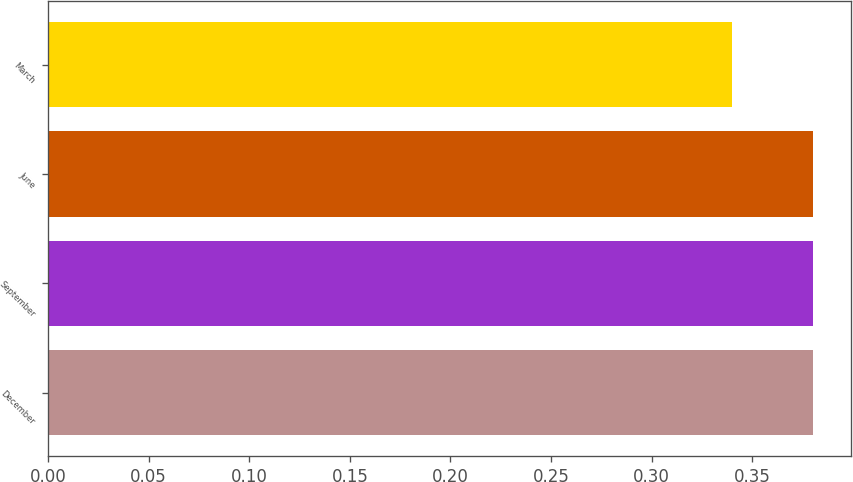<chart> <loc_0><loc_0><loc_500><loc_500><bar_chart><fcel>December<fcel>September<fcel>June<fcel>March<nl><fcel>0.38<fcel>0.38<fcel>0.38<fcel>0.34<nl></chart> 